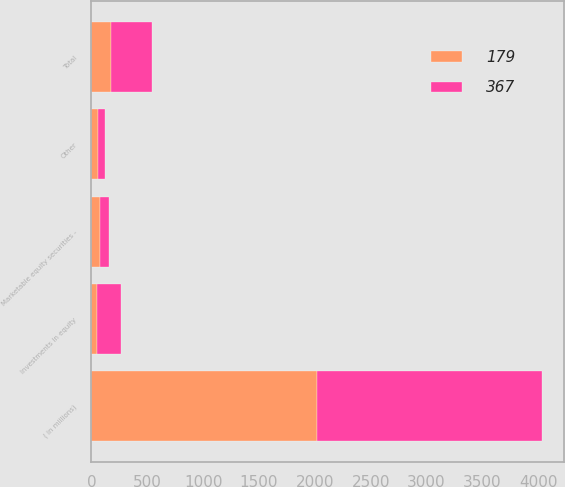<chart> <loc_0><loc_0><loc_500><loc_500><stacked_bar_chart><ecel><fcel>( in millions)<fcel>Investments in equity<fcel>Marketable equity securities -<fcel>Other<fcel>Total<nl><fcel>179<fcel>2016<fcel>46<fcel>78<fcel>55<fcel>179<nl><fcel>367<fcel>2015<fcel>221<fcel>77<fcel>69<fcel>367<nl></chart> 